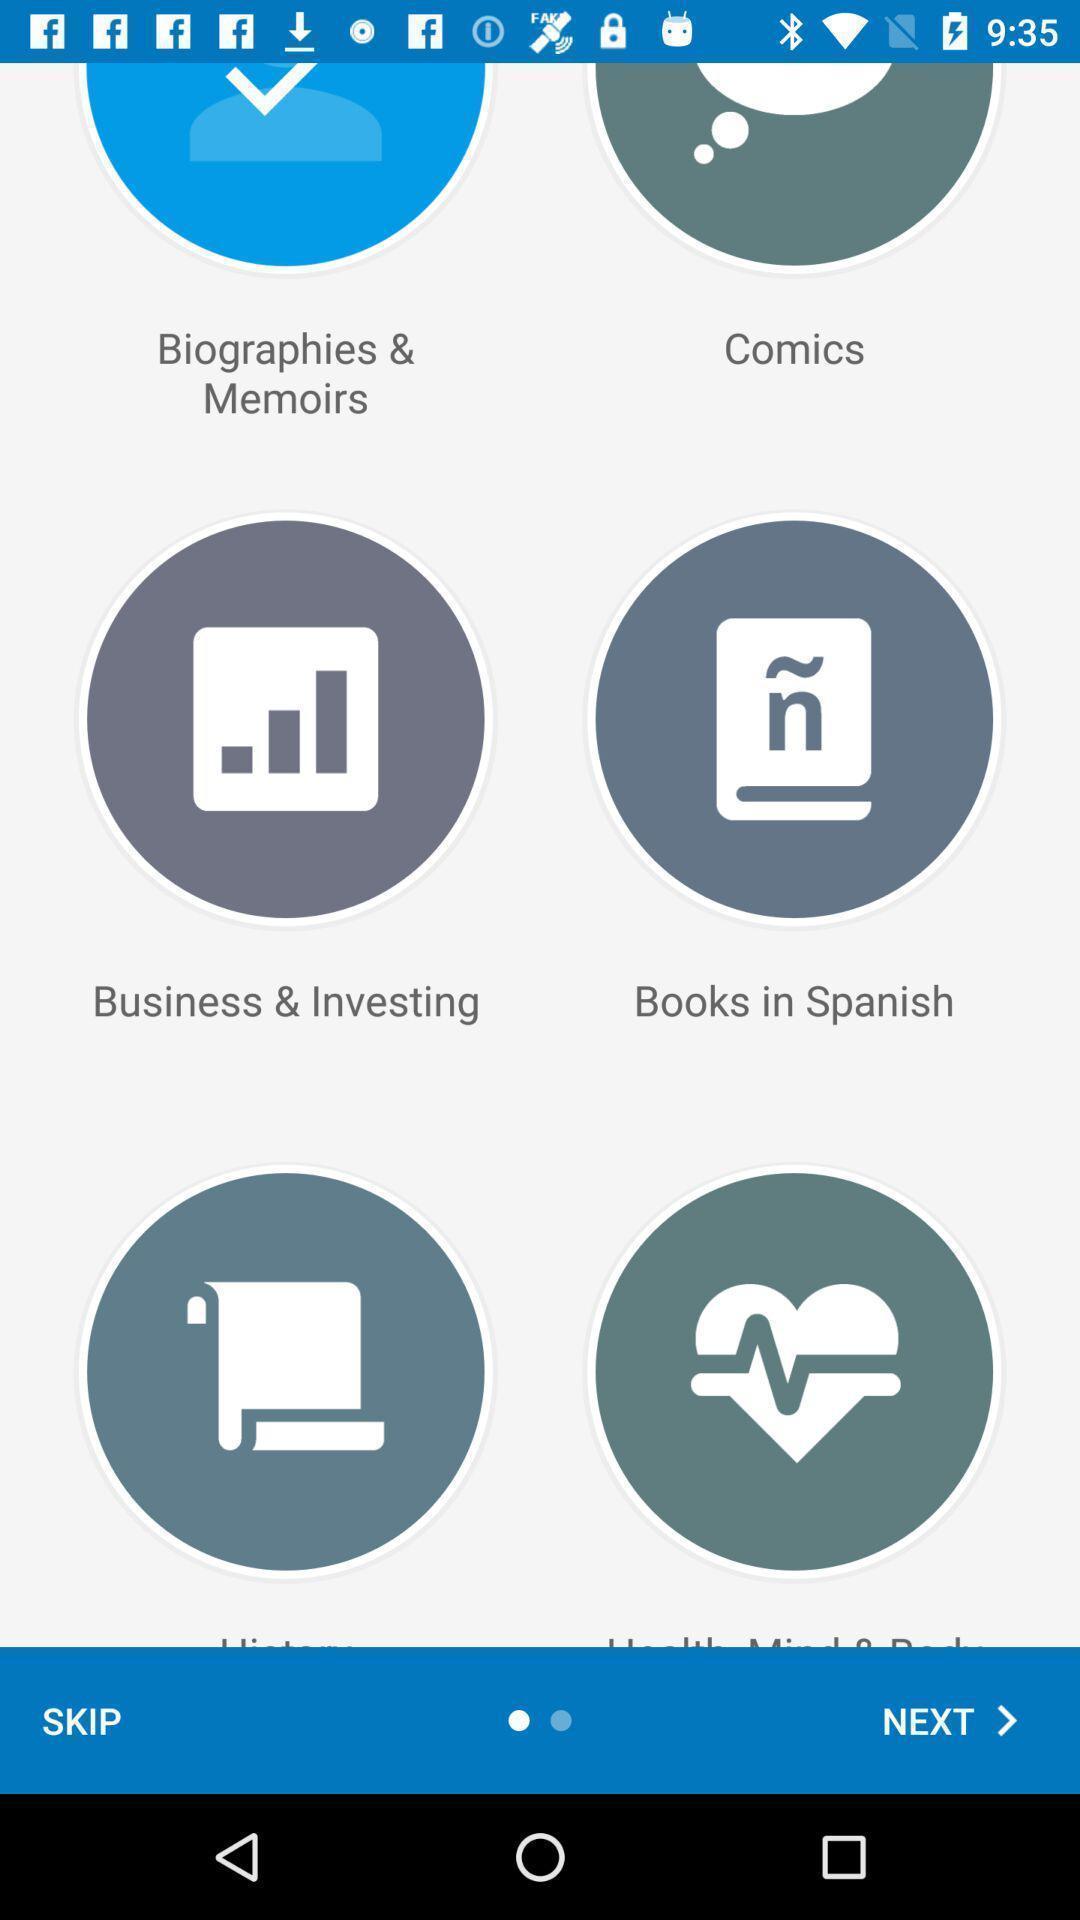Summarize the main components in this picture. Screen displaying list of ebooks. 